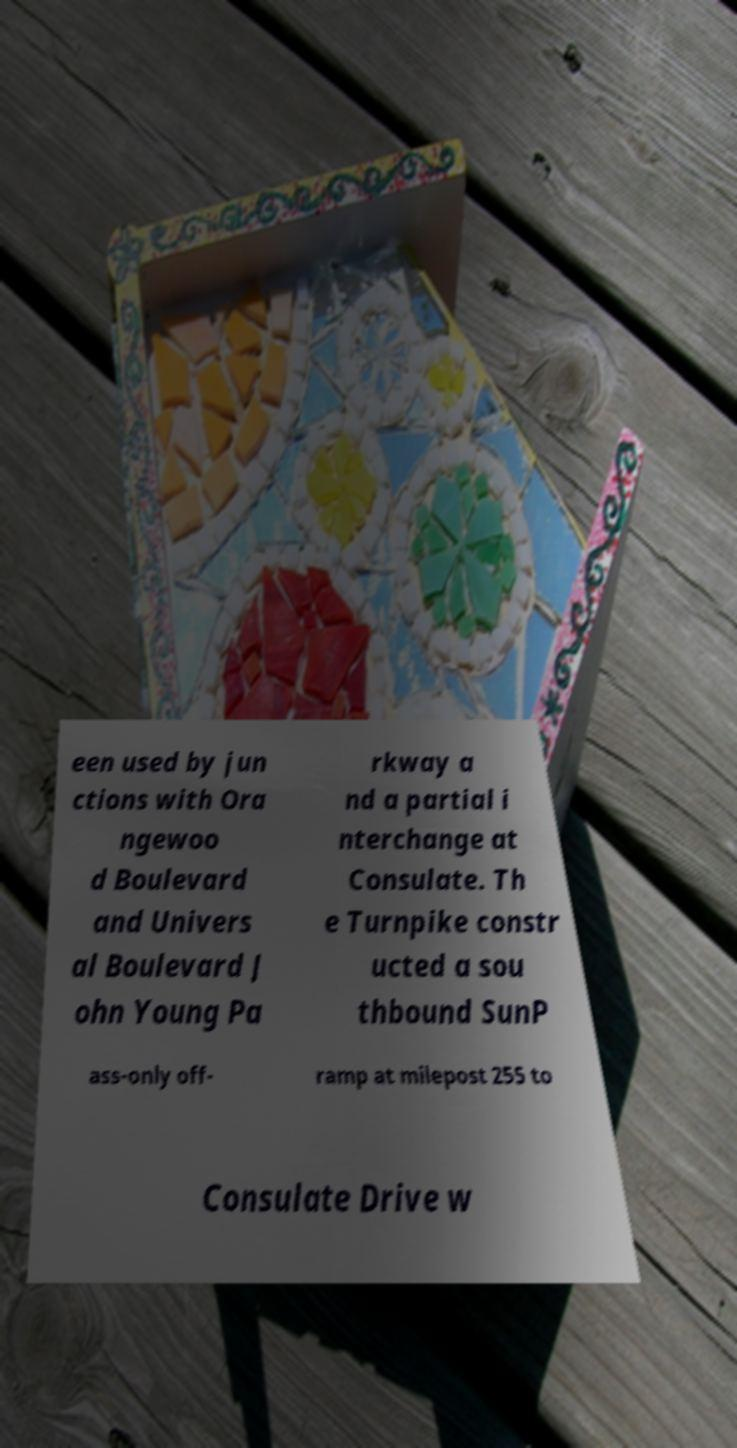What messages or text are displayed in this image? I need them in a readable, typed format. een used by jun ctions with Ora ngewoo d Boulevard and Univers al Boulevard J ohn Young Pa rkway a nd a partial i nterchange at Consulate. Th e Turnpike constr ucted a sou thbound SunP ass-only off- ramp at milepost 255 to Consulate Drive w 